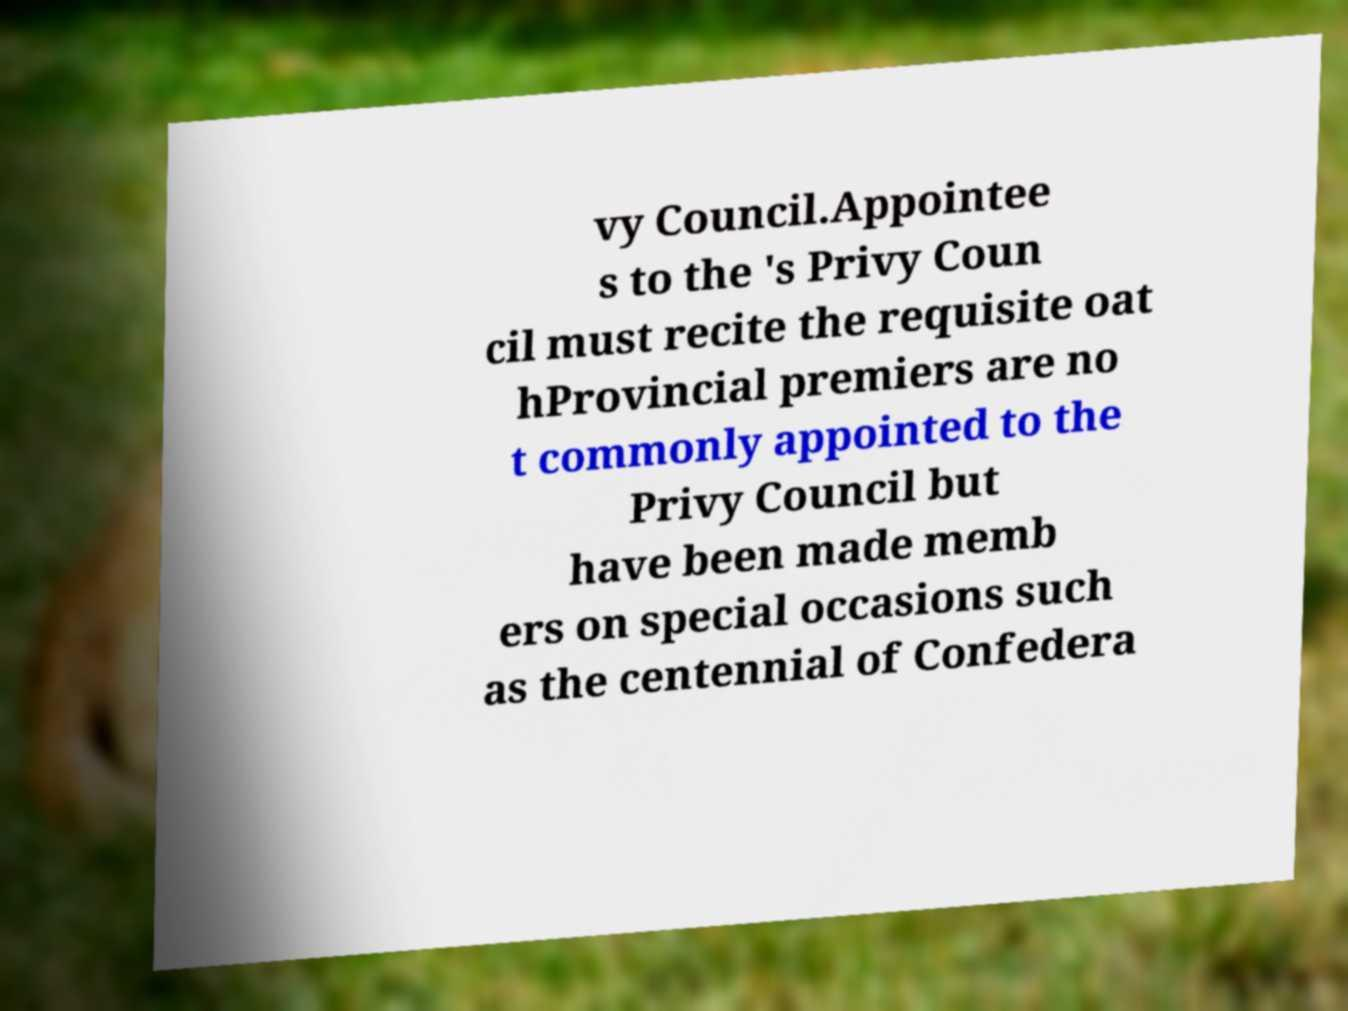Please read and relay the text visible in this image. What does it say? vy Council.Appointee s to the 's Privy Coun cil must recite the requisite oat hProvincial premiers are no t commonly appointed to the Privy Council but have been made memb ers on special occasions such as the centennial of Confedera 